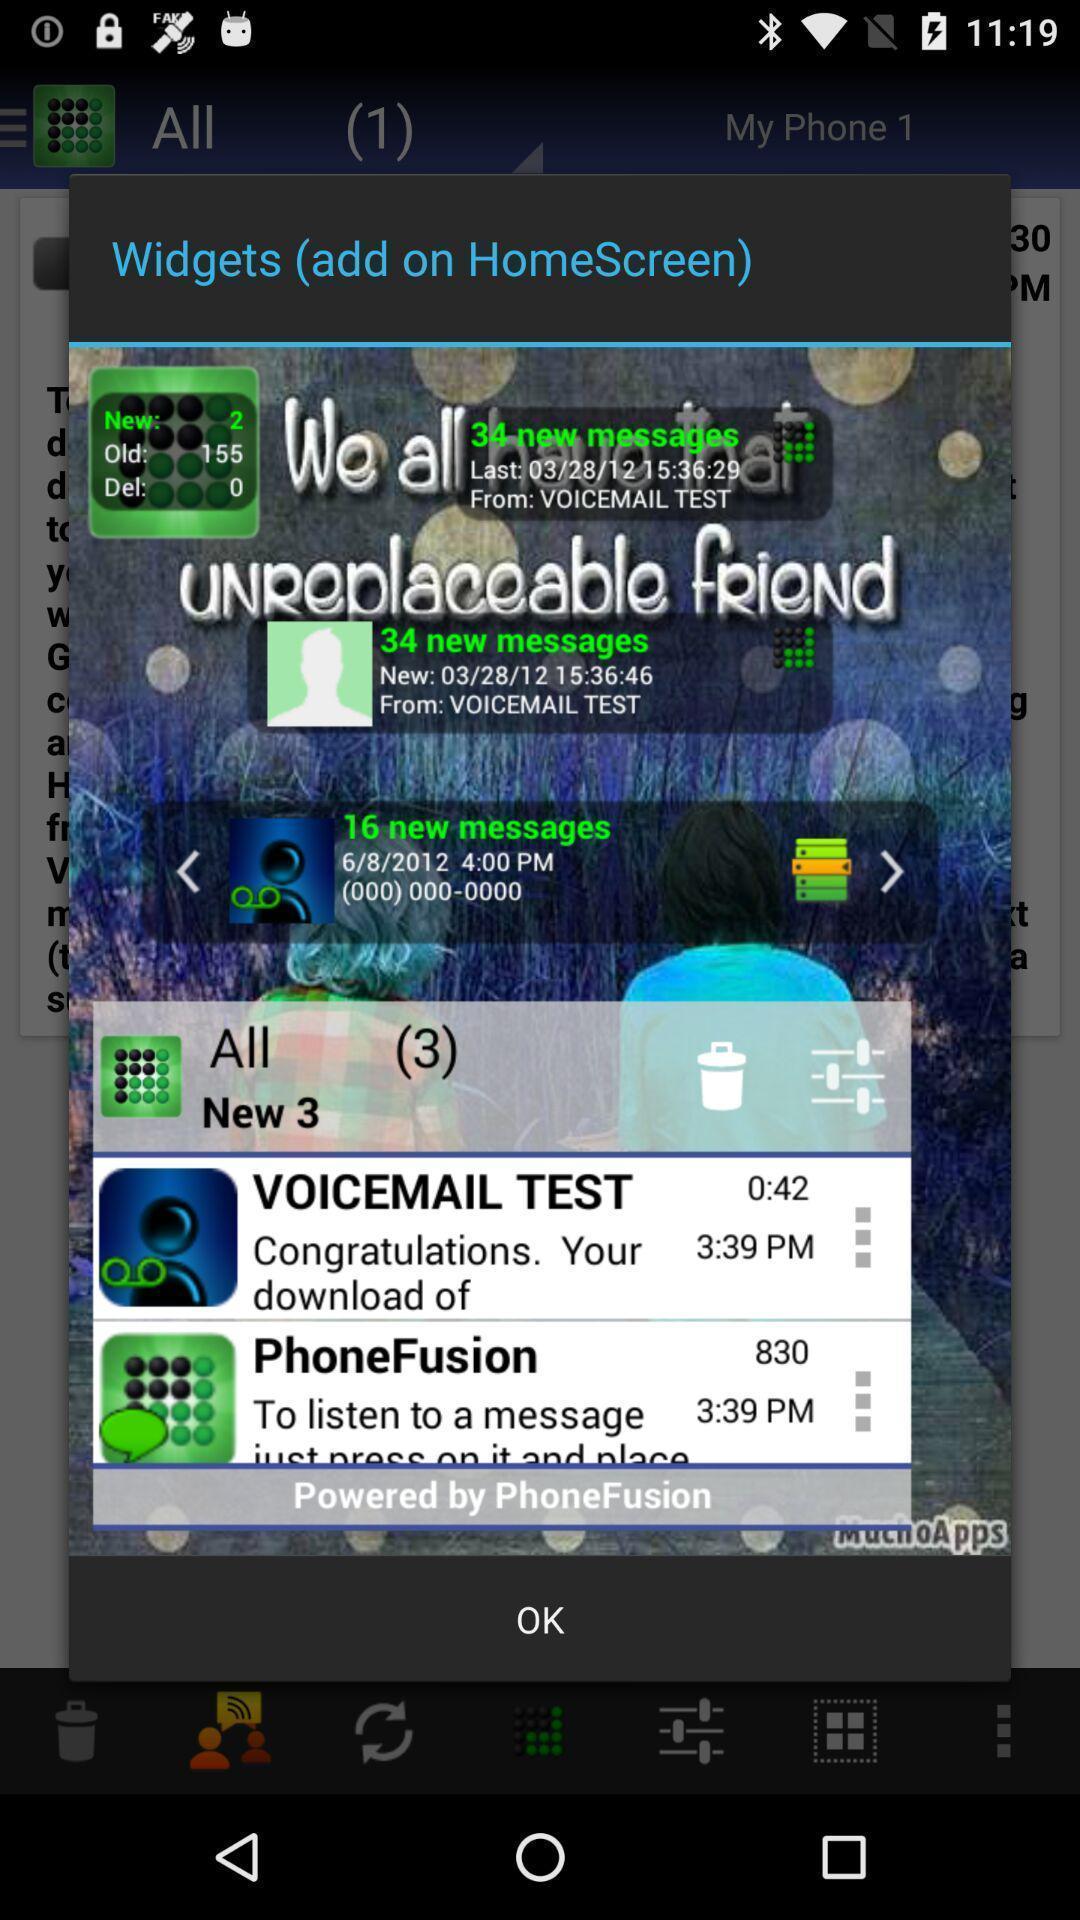Tell me what you see in this picture. Pop-up showing a widget to add. 